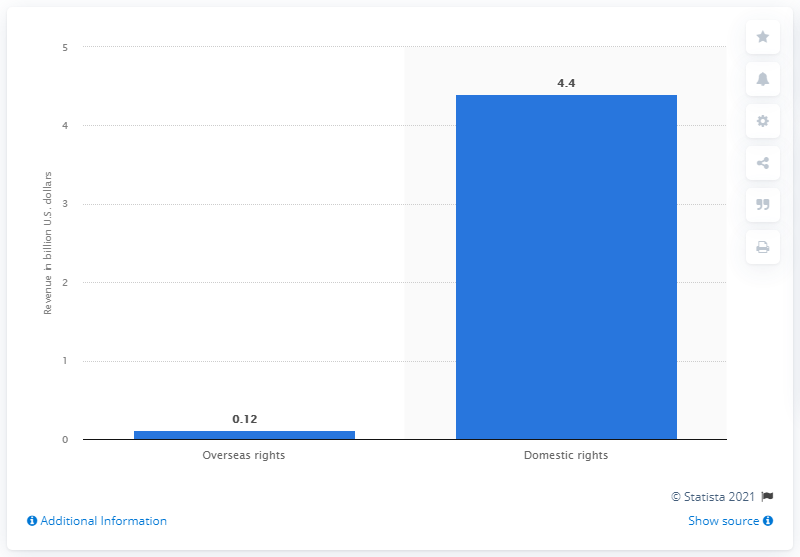Point out several critical features in this image. In 2019, the National Football League (NFL) generated approximately $4.4 billion from domestic rights. The NFL generated approximately 0.12 billion USD from overseas rights in 2019. 